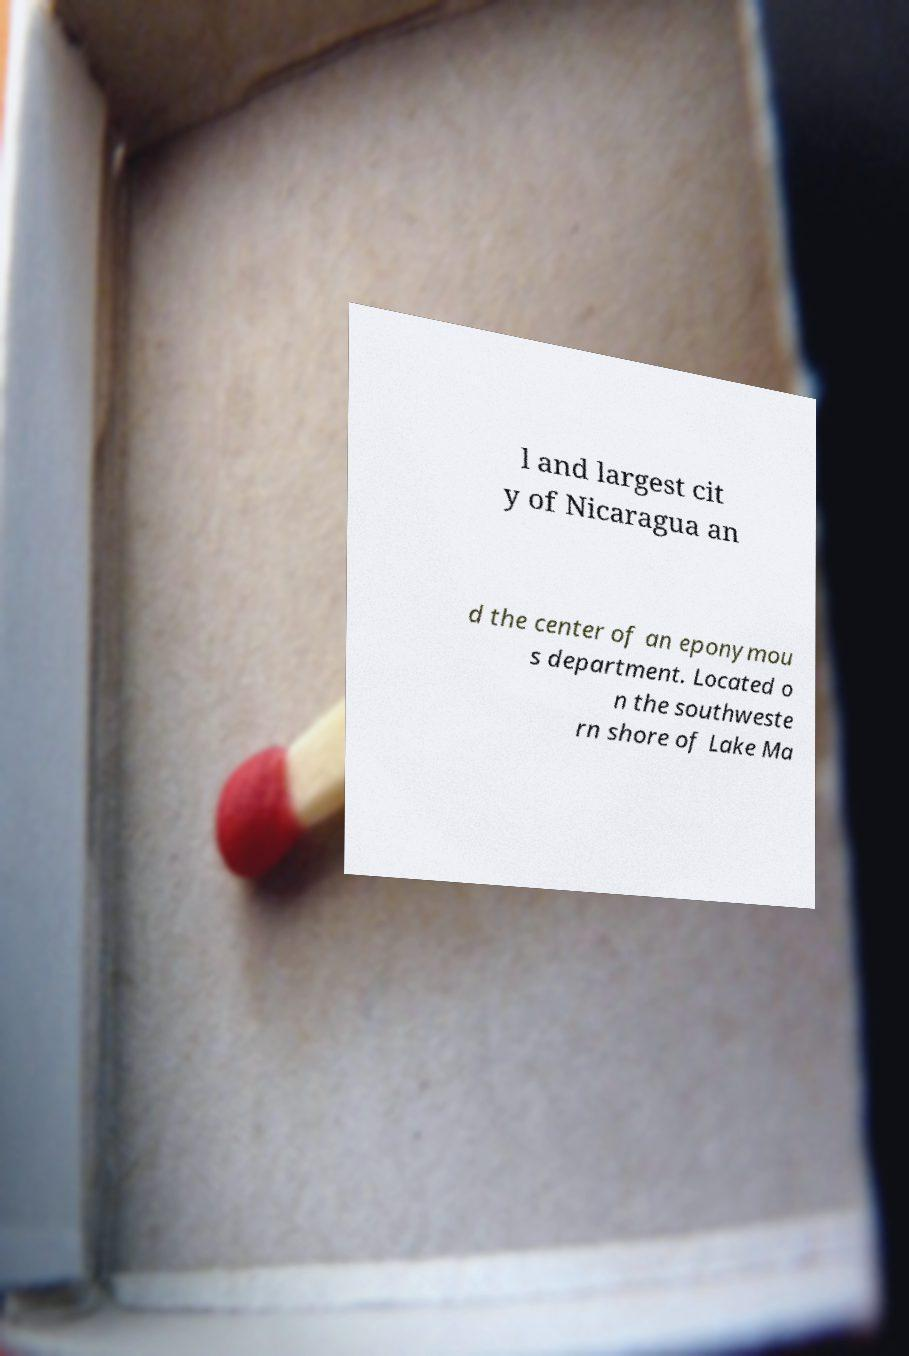Can you read and provide the text displayed in the image?This photo seems to have some interesting text. Can you extract and type it out for me? l and largest cit y of Nicaragua an d the center of an eponymou s department. Located o n the southweste rn shore of Lake Ma 